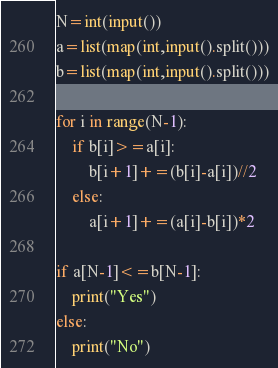<code> <loc_0><loc_0><loc_500><loc_500><_Python_>N=int(input())
a=list(map(int,input().split()))
b=list(map(int,input().split()))

for i in range(N-1):
    if b[i]>=a[i]:
        b[i+1]+=(b[i]-a[i])//2
    else:
        a[i+1]+=(a[i]-b[i])*2

if a[N-1]<=b[N-1]:
    print("Yes")
else:
    print("No")</code> 